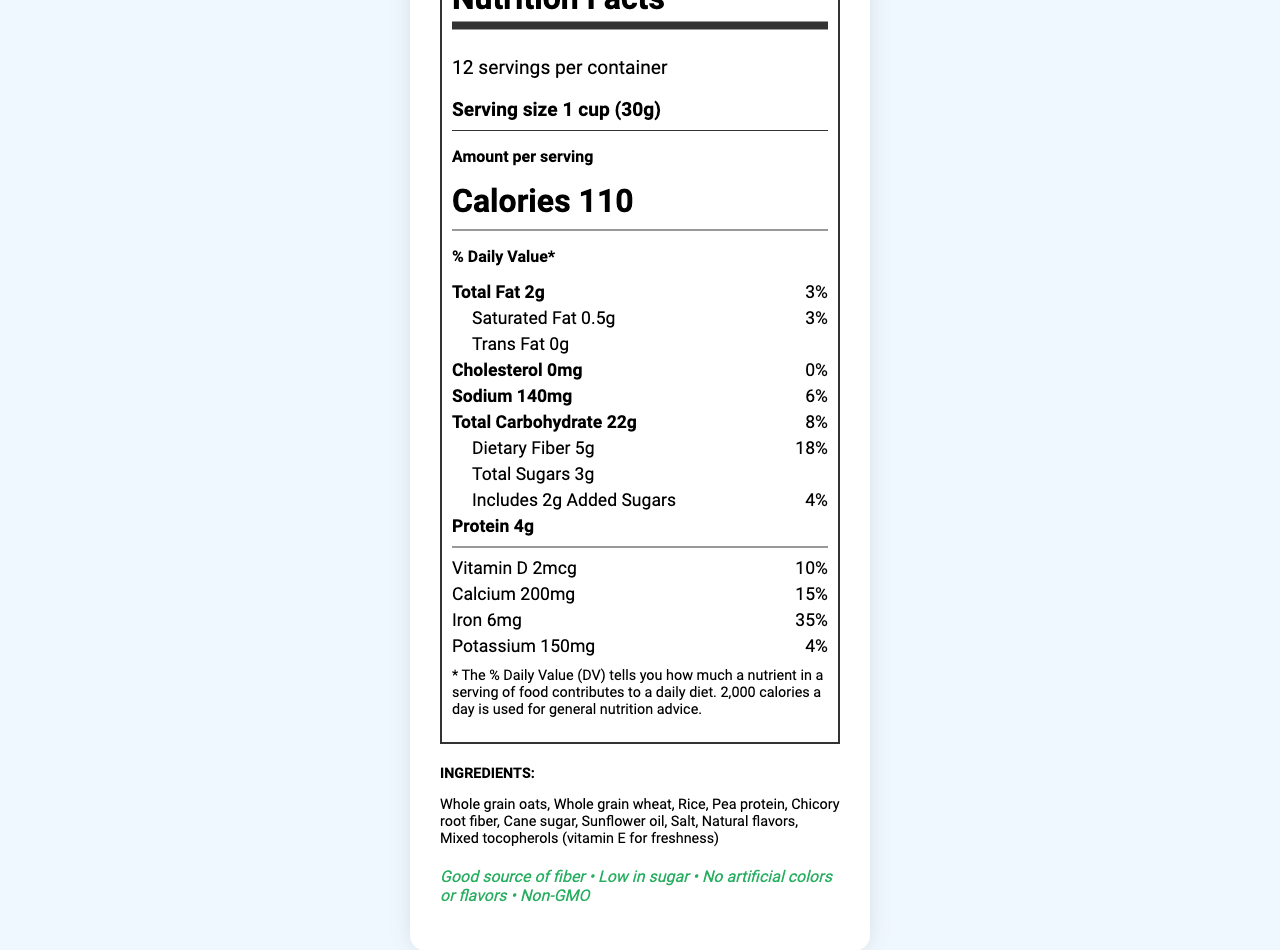what is the serving size of Fiber Crunch Revolution? The serving size is listed as "1 cup (30g)" in the document.
Answer: 1 cup (30g) how many servings are in a container? The document states there are 12 servings per container.
Answer: 12 what is the total fat content per serving? The total fat content per serving is given as "2g".
Answer: 2g how much fiber does a serving contain? Each serving contains "5g" of dietary fiber.
Answer: 5g what is the percentage daily value of iron per serving? The % daily value of iron per serving is listed as "35%".
Answer: 35% which of the following ingredients are in the product? A. Corn, B. Whole grain oats, C. Coconut oil, D. Honey Whole grain oats are listed in the ingredients, while corn, coconut oil, and honey are not.
Answer: B what nutrient has the highest % daily value per serving? A. Sodium, B. Total fat, C. Iron, D. Vitamin D Iron has the highest % daily value per serving at 35%.
Answer: C does this product contain trans fat? The document states the trans fat content is "0g".
Answer: No is this product non-GMO? One of the health claims listed is "Non-GMO".
Answer: Yes provide a summary of the main marketing claims and targeted features of this product. The main marketing claims include high fiber content for digestive health, low sugar for weight management, and sustained energy from whole grains. Additionally, the product focuses on sustainability and natural ingredients.
Answer: This product is a low-sugar, high-fiber breakfast cereal named Fiber Crunch Revolution aimed at health-conscious millennials. It claims to be a good source of fiber, low in sugar, non-GMO, and free from artificial colors and flavors. The product is also packaged in recyclable materials and sources its ingredients from sustainable farms. what is the average fiber content per serving of competitors' products? The marketing data specifies that the average fiber content of competitors' products is 2g per serving.
Answer: 2g per serving does this product contain milk or soy? The allergen information indicates that the product may contain milk and soy.
Answer: May contain milk and soy what is the repurchase intent of the customers? The customer insights section states that repurchase intent is 72%.
Answer: 72% how much potassium is in each serving? The product contains 150mg of potassium per serving.
Answer: 150mg are there any artificial colors or flavors in the product? One of the health claims listed is "No artificial colors or flavors".
Answer: No what are the most appreciated features by customers? Customer insights highlight these features as the most appreciated by customers.
Answer: Low sugar content, high fiber, and satisfying crunch which feature is not mentioned in the document? A. Low sugar content, B. High protein content, C. Satisfying crunch The document does not mention "High protein content" as a key feature; instead, it focuses on low sugar content and a satisfying crunch.
Answer: B where are the ingredients sourced from? The sustainability information states that ingredients are sourced from sustainable farms.
Answer: Sustainable farms describe the taste rating of this product. The customer insights section provides a taste rating of 4.2.
Answer: 4.2 what is the average sugar content per serving of competitors' products? The document mentions that the average sugar content of competitors' products is 12g per serving.
Answer: 12g per serving is the protein content considered high? The document does not provide a comparison or a benchmark to determine whether the protein content of 4g per serving is considered high.
Answer: Cannot be determined 